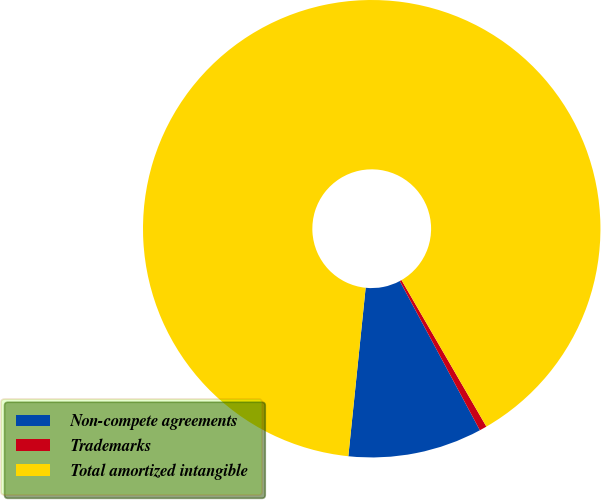Convert chart to OTSL. <chart><loc_0><loc_0><loc_500><loc_500><pie_chart><fcel>Non-compete agreements<fcel>Trademarks<fcel>Total amortized intangible<nl><fcel>9.47%<fcel>0.52%<fcel>90.01%<nl></chart> 